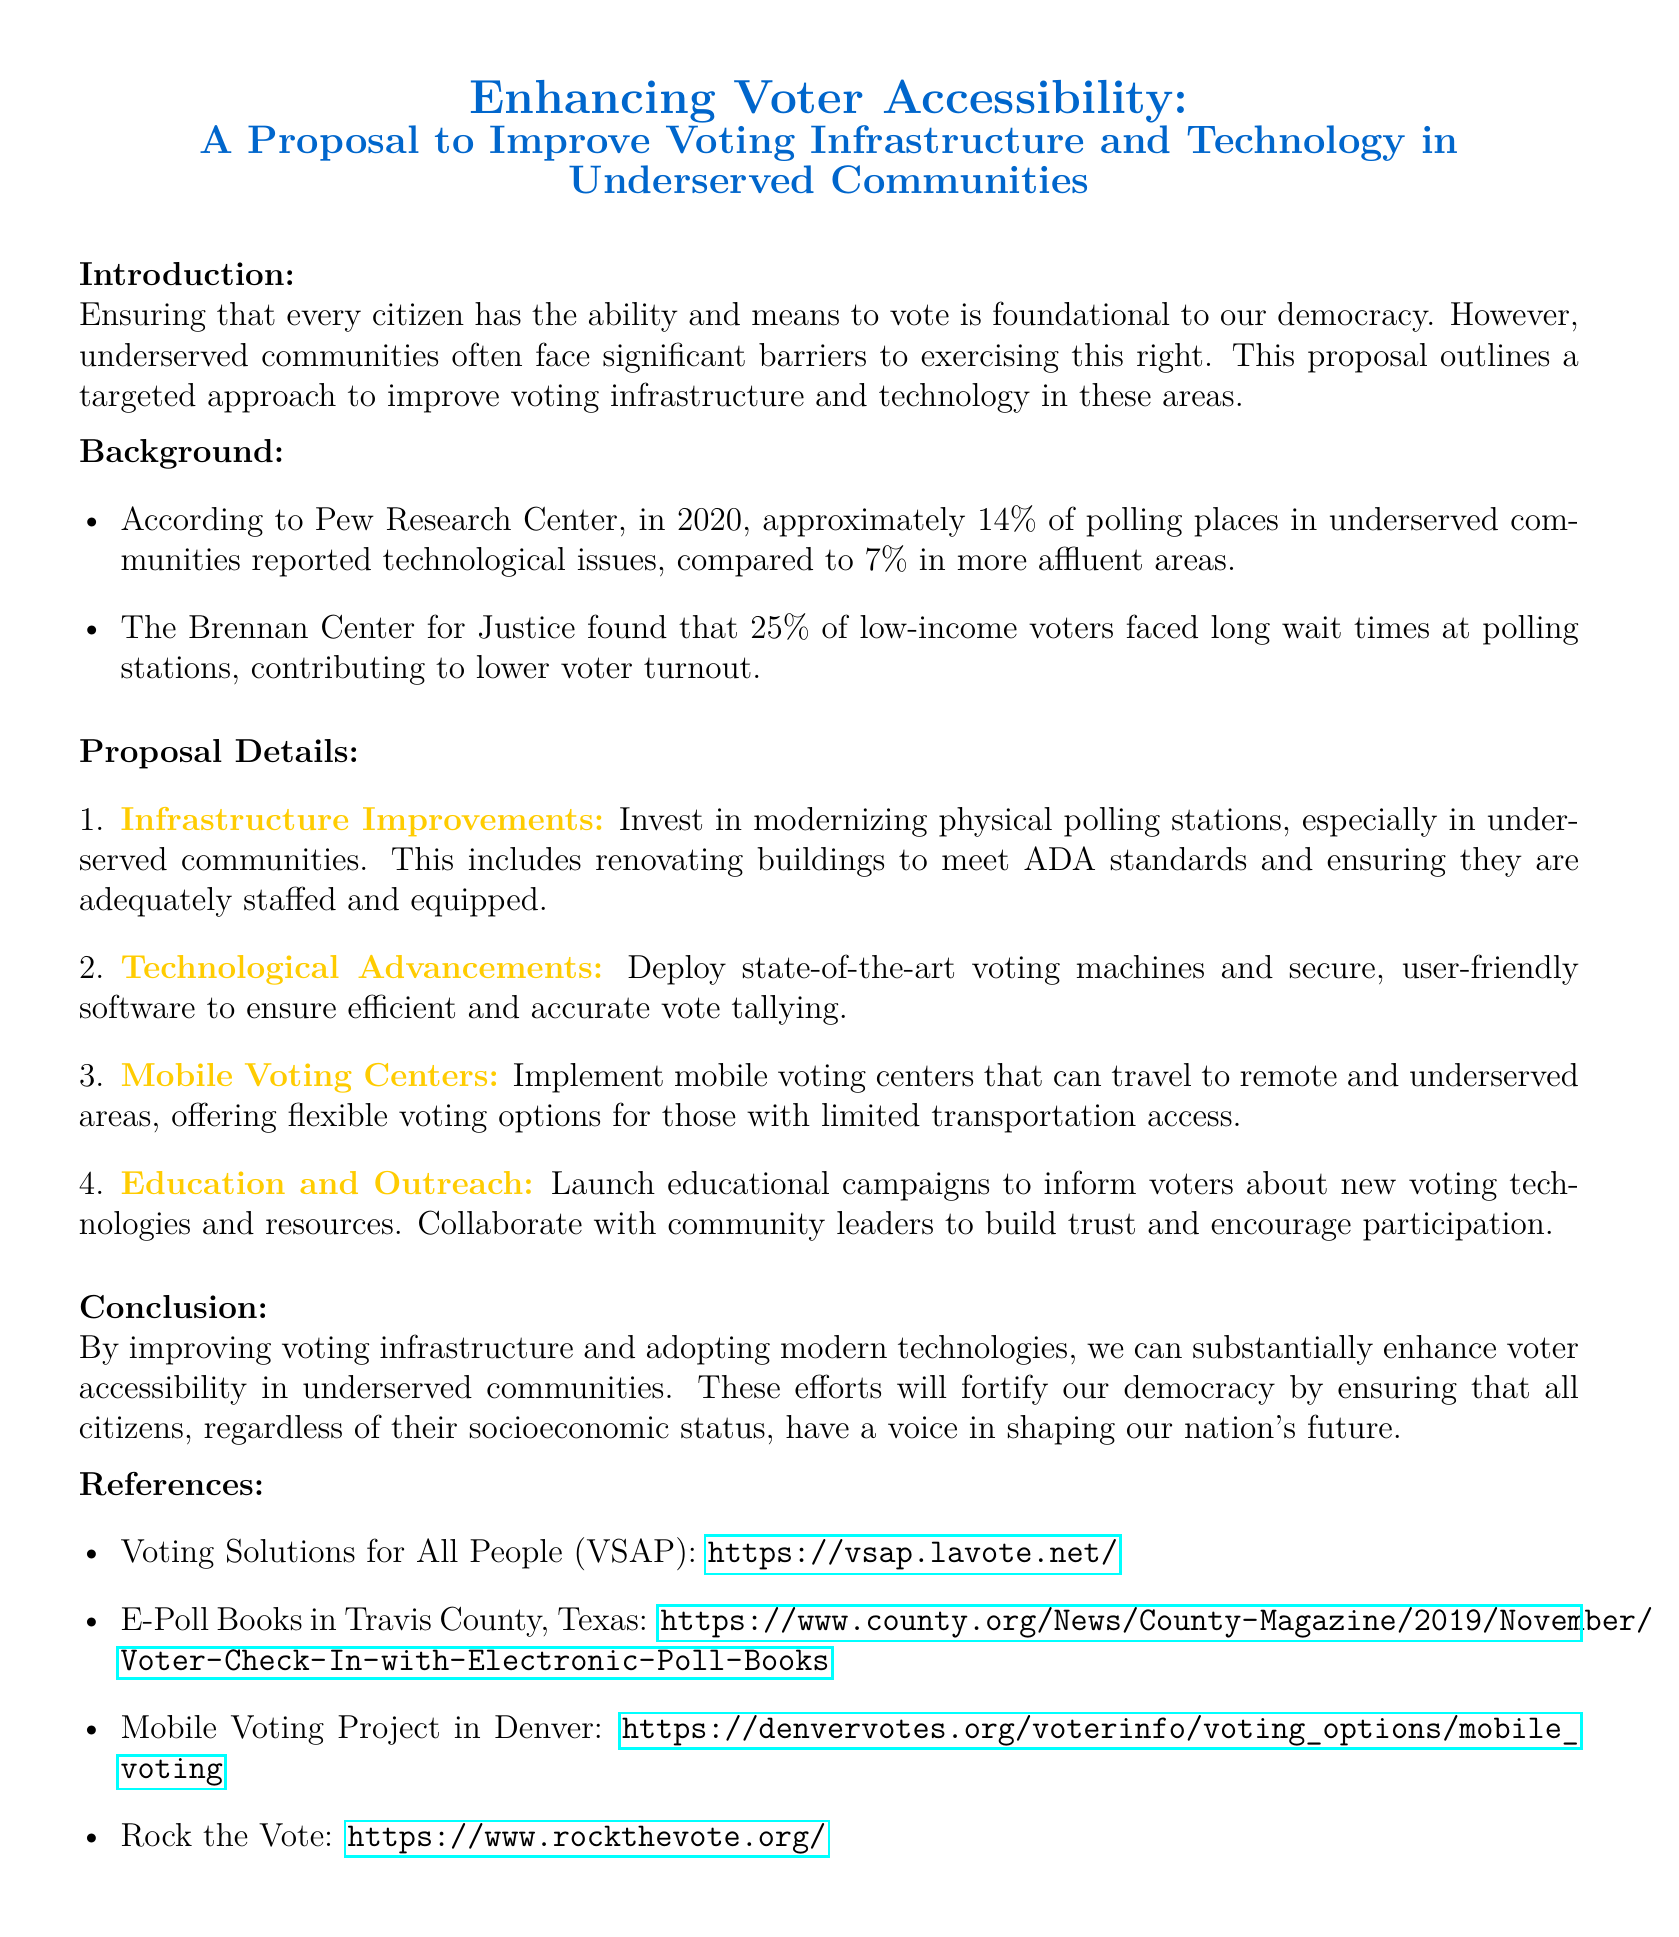what percentage of polling places in underserved communities reported technological issues? According to the Pew Research Center, approximately 14% of polling places in underserved communities reported technological issues.
Answer: 14% what is one of the main goals of the proposal? The proposal aims to improve voting infrastructure and technology in underserved communities, enhancing voter accessibility.
Answer: Enhance voter accessibility what does the proposal suggest for physical polling stations? The proposal recommends investing in modernizing physical polling stations to meet ADA standards and ensuring they are adequately staffed and equipped.
Answer: Modernizing physical polling stations how many low-income voters faced long wait times at polling stations? The Brennan Center for Justice found that 25% of low-income voters faced long wait times.
Answer: 25% what is a proposed method to reach remote areas for voting? The proposal includes implementing mobile voting centers that can travel to remote and underserved areas.
Answer: Mobile voting centers what initiative is suggested for educating voters? The proposal outlines launching educational campaigns to inform voters about new voting technologies and resources.
Answer: Educational campaigns what kind of technology does the proposal advocate for voting machines? The proposal advocates for state-of-the-art voting machines and secure, user-friendly software.
Answer: State-of-the-art voting machines who should be collaborated with to encourage participation? The proposal suggests collaborating with community leaders to build trust and encourage voter participation.
Answer: Community leaders 